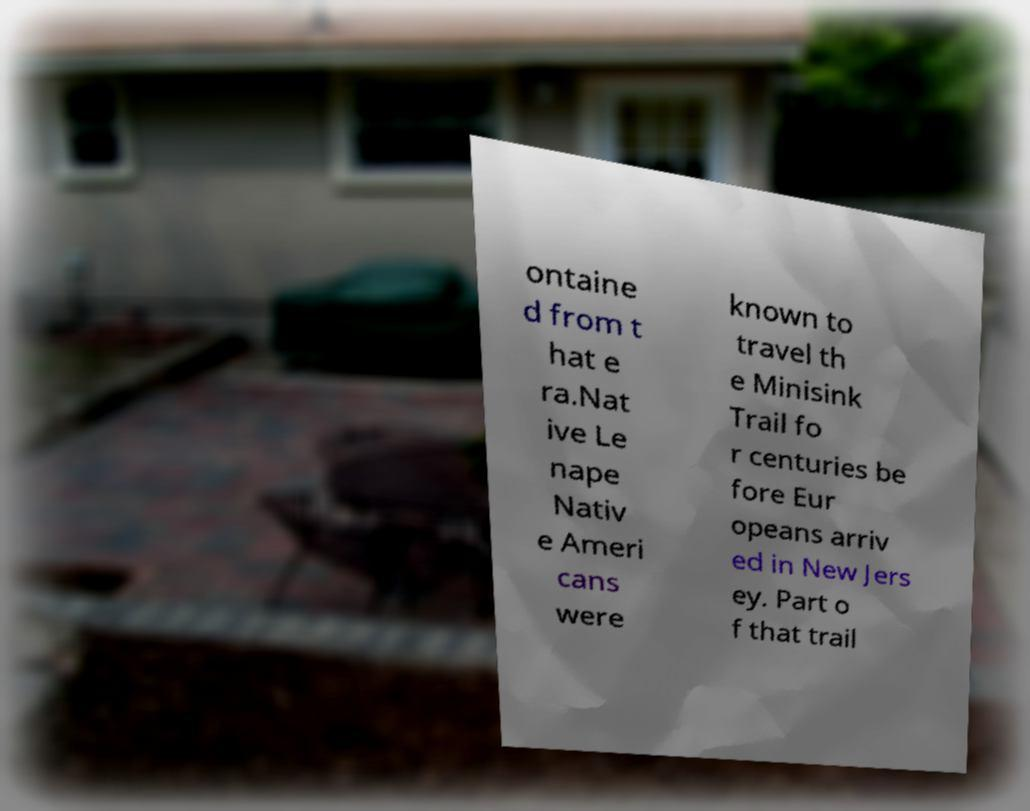Could you extract and type out the text from this image? ontaine d from t hat e ra.Nat ive Le nape Nativ e Ameri cans were known to travel th e Minisink Trail fo r centuries be fore Eur opeans arriv ed in New Jers ey. Part o f that trail 